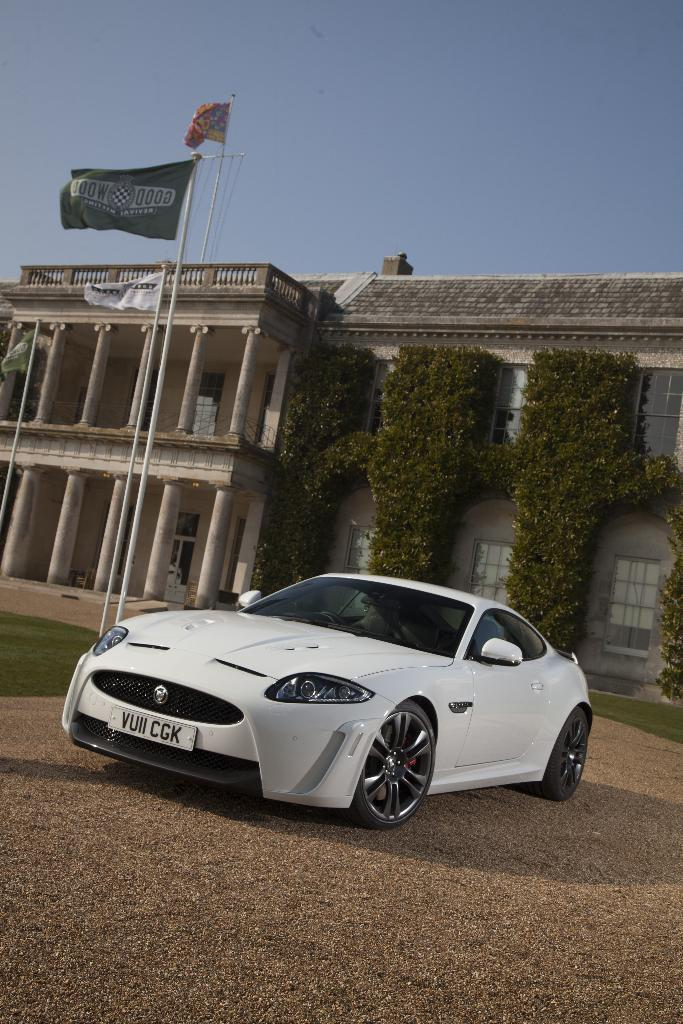What is the main subject in the middle of the image? There is a car in the middle of the image. What can be seen in the background of the image? There are flags, a building, and wall shrubs in the background of the image. How many guns are visible in the image? There are no guns present in the image. What force is being applied to the car in the image? There is no force being applied to the car in the image; it is stationary. 